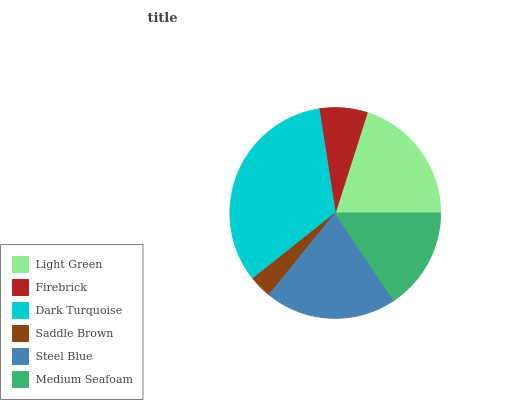Is Saddle Brown the minimum?
Answer yes or no. Yes. Is Dark Turquoise the maximum?
Answer yes or no. Yes. Is Firebrick the minimum?
Answer yes or no. No. Is Firebrick the maximum?
Answer yes or no. No. Is Light Green greater than Firebrick?
Answer yes or no. Yes. Is Firebrick less than Light Green?
Answer yes or no. Yes. Is Firebrick greater than Light Green?
Answer yes or no. No. Is Light Green less than Firebrick?
Answer yes or no. No. Is Light Green the high median?
Answer yes or no. Yes. Is Medium Seafoam the low median?
Answer yes or no. Yes. Is Saddle Brown the high median?
Answer yes or no. No. Is Light Green the low median?
Answer yes or no. No. 